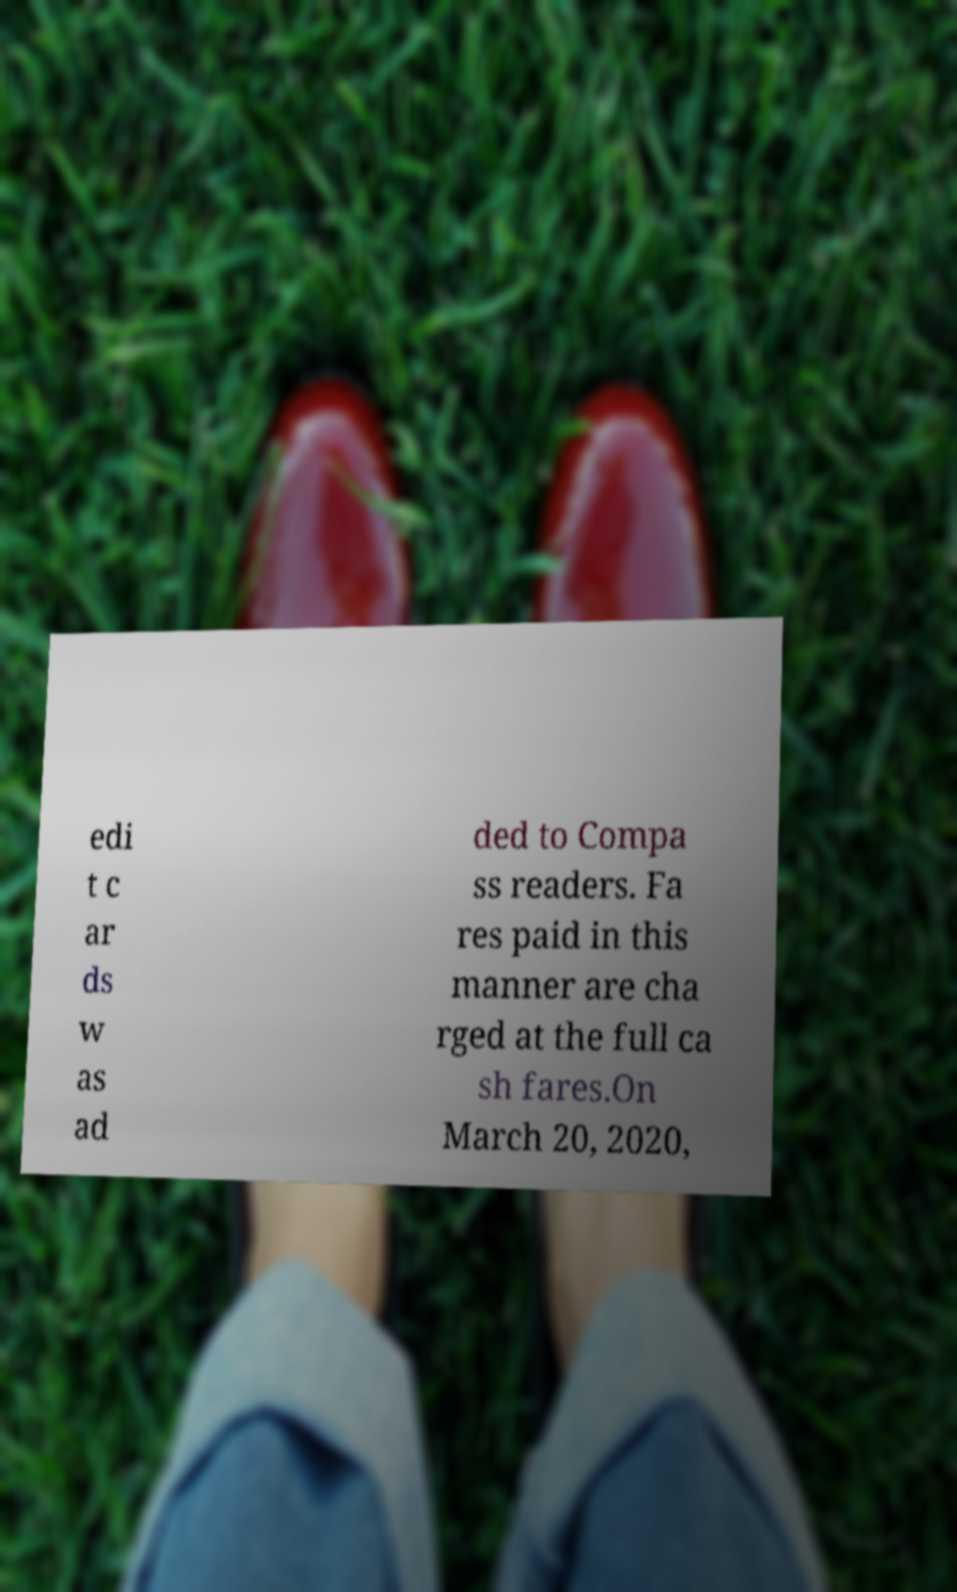What messages or text are displayed in this image? I need them in a readable, typed format. edi t c ar ds w as ad ded to Compa ss readers. Fa res paid in this manner are cha rged at the full ca sh fares.On March 20, 2020, 